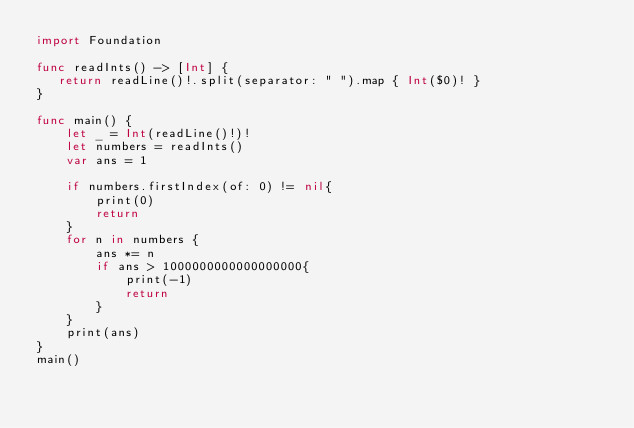Convert code to text. <code><loc_0><loc_0><loc_500><loc_500><_Swift_>import Foundation

func readInts() -> [Int] {
   return readLine()!.split(separator: " ").map { Int($0)! }
}

func main() {
    let _ = Int(readLine()!)!
    let numbers = readInts()
    var ans = 1
    
    if numbers.firstIndex(of: 0) != nil{
        print(0)
        return
    }
    for n in numbers {
        ans *= n
        if ans > 1000000000000000000{
            print(-1)
            return
        }
    }
    print(ans)
}
main()
</code> 